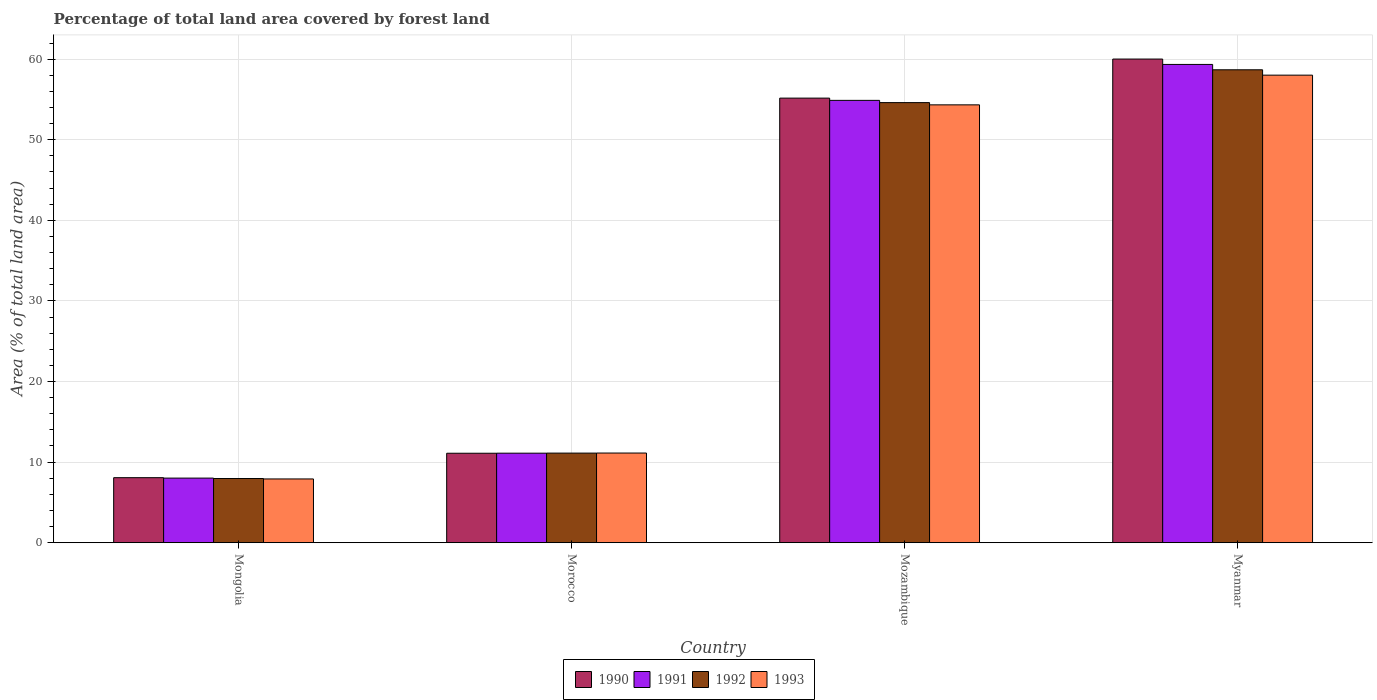How many different coloured bars are there?
Provide a short and direct response. 4. How many groups of bars are there?
Offer a terse response. 4. Are the number of bars per tick equal to the number of legend labels?
Offer a terse response. Yes. Are the number of bars on each tick of the X-axis equal?
Give a very brief answer. Yes. How many bars are there on the 2nd tick from the right?
Ensure brevity in your answer.  4. What is the label of the 4th group of bars from the left?
Provide a succinct answer. Myanmar. What is the percentage of forest land in 1991 in Myanmar?
Provide a succinct answer. 59.34. Across all countries, what is the maximum percentage of forest land in 1992?
Your response must be concise. 58.68. Across all countries, what is the minimum percentage of forest land in 1990?
Provide a succinct answer. 8.07. In which country was the percentage of forest land in 1992 maximum?
Provide a succinct answer. Myanmar. In which country was the percentage of forest land in 1990 minimum?
Give a very brief answer. Mongolia. What is the total percentage of forest land in 1992 in the graph?
Provide a short and direct response. 132.36. What is the difference between the percentage of forest land in 1993 in Mongolia and that in Mozambique?
Keep it short and to the point. -46.42. What is the difference between the percentage of forest land in 1992 in Mozambique and the percentage of forest land in 1993 in Morocco?
Provide a short and direct response. 43.48. What is the average percentage of forest land in 1990 per country?
Provide a short and direct response. 33.58. What is the difference between the percentage of forest land of/in 1993 and percentage of forest land of/in 1990 in Mongolia?
Your answer should be very brief. -0.16. What is the ratio of the percentage of forest land in 1993 in Mongolia to that in Myanmar?
Offer a very short reply. 0.14. Is the difference between the percentage of forest land in 1993 in Morocco and Myanmar greater than the difference between the percentage of forest land in 1990 in Morocco and Myanmar?
Make the answer very short. Yes. What is the difference between the highest and the second highest percentage of forest land in 1992?
Make the answer very short. 47.56. What is the difference between the highest and the lowest percentage of forest land in 1990?
Provide a succinct answer. 51.94. Is the sum of the percentage of forest land in 1993 in Morocco and Myanmar greater than the maximum percentage of forest land in 1990 across all countries?
Provide a short and direct response. Yes. What does the 2nd bar from the left in Mozambique represents?
Your answer should be very brief. 1991. Are all the bars in the graph horizontal?
Your answer should be compact. No. How many countries are there in the graph?
Keep it short and to the point. 4. What is the difference between two consecutive major ticks on the Y-axis?
Keep it short and to the point. 10. Are the values on the major ticks of Y-axis written in scientific E-notation?
Provide a succinct answer. No. Does the graph contain any zero values?
Offer a terse response. No. How are the legend labels stacked?
Provide a succinct answer. Horizontal. What is the title of the graph?
Your answer should be compact. Percentage of total land area covered by forest land. Does "2003" appear as one of the legend labels in the graph?
Keep it short and to the point. No. What is the label or title of the X-axis?
Keep it short and to the point. Country. What is the label or title of the Y-axis?
Your response must be concise. Area (% of total land area). What is the Area (% of total land area) in 1990 in Mongolia?
Offer a very short reply. 8.07. What is the Area (% of total land area) of 1991 in Mongolia?
Give a very brief answer. 8.02. What is the Area (% of total land area) in 1992 in Mongolia?
Your answer should be very brief. 7.96. What is the Area (% of total land area) of 1993 in Mongolia?
Provide a short and direct response. 7.91. What is the Area (% of total land area) of 1990 in Morocco?
Give a very brief answer. 11.1. What is the Area (% of total land area) of 1991 in Morocco?
Offer a terse response. 11.11. What is the Area (% of total land area) of 1992 in Morocco?
Ensure brevity in your answer.  11.12. What is the Area (% of total land area) of 1993 in Morocco?
Your response must be concise. 11.13. What is the Area (% of total land area) of 1990 in Mozambique?
Ensure brevity in your answer.  55.16. What is the Area (% of total land area) in 1991 in Mozambique?
Provide a succinct answer. 54.88. What is the Area (% of total land area) of 1992 in Mozambique?
Your answer should be very brief. 54.6. What is the Area (% of total land area) of 1993 in Mozambique?
Offer a terse response. 54.33. What is the Area (% of total land area) in 1990 in Myanmar?
Ensure brevity in your answer.  60.01. What is the Area (% of total land area) of 1991 in Myanmar?
Your answer should be very brief. 59.34. What is the Area (% of total land area) in 1992 in Myanmar?
Ensure brevity in your answer.  58.68. What is the Area (% of total land area) in 1993 in Myanmar?
Your answer should be very brief. 58.01. Across all countries, what is the maximum Area (% of total land area) in 1990?
Keep it short and to the point. 60.01. Across all countries, what is the maximum Area (% of total land area) in 1991?
Give a very brief answer. 59.34. Across all countries, what is the maximum Area (% of total land area) in 1992?
Your answer should be very brief. 58.68. Across all countries, what is the maximum Area (% of total land area) in 1993?
Offer a very short reply. 58.01. Across all countries, what is the minimum Area (% of total land area) in 1990?
Your answer should be very brief. 8.07. Across all countries, what is the minimum Area (% of total land area) of 1991?
Your answer should be very brief. 8.02. Across all countries, what is the minimum Area (% of total land area) in 1992?
Make the answer very short. 7.96. Across all countries, what is the minimum Area (% of total land area) of 1993?
Ensure brevity in your answer.  7.91. What is the total Area (% of total land area) of 1990 in the graph?
Ensure brevity in your answer.  134.34. What is the total Area (% of total land area) of 1991 in the graph?
Your answer should be compact. 133.35. What is the total Area (% of total land area) of 1992 in the graph?
Offer a very short reply. 132.36. What is the total Area (% of total land area) of 1993 in the graph?
Your answer should be compact. 131.38. What is the difference between the Area (% of total land area) of 1990 in Mongolia and that in Morocco?
Keep it short and to the point. -3.03. What is the difference between the Area (% of total land area) of 1991 in Mongolia and that in Morocco?
Your response must be concise. -3.09. What is the difference between the Area (% of total land area) in 1992 in Mongolia and that in Morocco?
Give a very brief answer. -3.15. What is the difference between the Area (% of total land area) of 1993 in Mongolia and that in Morocco?
Keep it short and to the point. -3.22. What is the difference between the Area (% of total land area) in 1990 in Mongolia and that in Mozambique?
Provide a succinct answer. -47.09. What is the difference between the Area (% of total land area) of 1991 in Mongolia and that in Mozambique?
Make the answer very short. -46.87. What is the difference between the Area (% of total land area) of 1992 in Mongolia and that in Mozambique?
Offer a terse response. -46.64. What is the difference between the Area (% of total land area) in 1993 in Mongolia and that in Mozambique?
Your answer should be very brief. -46.42. What is the difference between the Area (% of total land area) of 1990 in Mongolia and that in Myanmar?
Offer a very short reply. -51.94. What is the difference between the Area (% of total land area) in 1991 in Mongolia and that in Myanmar?
Provide a succinct answer. -51.33. What is the difference between the Area (% of total land area) in 1992 in Mongolia and that in Myanmar?
Make the answer very short. -50.71. What is the difference between the Area (% of total land area) of 1993 in Mongolia and that in Myanmar?
Your answer should be very brief. -50.1. What is the difference between the Area (% of total land area) in 1990 in Morocco and that in Mozambique?
Give a very brief answer. -44.06. What is the difference between the Area (% of total land area) in 1991 in Morocco and that in Mozambique?
Keep it short and to the point. -43.77. What is the difference between the Area (% of total land area) in 1992 in Morocco and that in Mozambique?
Provide a succinct answer. -43.49. What is the difference between the Area (% of total land area) in 1993 in Morocco and that in Mozambique?
Offer a terse response. -43.2. What is the difference between the Area (% of total land area) of 1990 in Morocco and that in Myanmar?
Ensure brevity in your answer.  -48.91. What is the difference between the Area (% of total land area) in 1991 in Morocco and that in Myanmar?
Ensure brevity in your answer.  -48.23. What is the difference between the Area (% of total land area) in 1992 in Morocco and that in Myanmar?
Make the answer very short. -47.56. What is the difference between the Area (% of total land area) in 1993 in Morocco and that in Myanmar?
Your answer should be compact. -46.89. What is the difference between the Area (% of total land area) in 1990 in Mozambique and that in Myanmar?
Keep it short and to the point. -4.85. What is the difference between the Area (% of total land area) of 1991 in Mozambique and that in Myanmar?
Give a very brief answer. -4.46. What is the difference between the Area (% of total land area) of 1992 in Mozambique and that in Myanmar?
Your response must be concise. -4.07. What is the difference between the Area (% of total land area) in 1993 in Mozambique and that in Myanmar?
Offer a terse response. -3.69. What is the difference between the Area (% of total land area) in 1990 in Mongolia and the Area (% of total land area) in 1991 in Morocco?
Offer a very short reply. -3.04. What is the difference between the Area (% of total land area) in 1990 in Mongolia and the Area (% of total land area) in 1992 in Morocco?
Ensure brevity in your answer.  -3.05. What is the difference between the Area (% of total land area) of 1990 in Mongolia and the Area (% of total land area) of 1993 in Morocco?
Keep it short and to the point. -3.06. What is the difference between the Area (% of total land area) of 1991 in Mongolia and the Area (% of total land area) of 1992 in Morocco?
Your answer should be compact. -3.1. What is the difference between the Area (% of total land area) in 1991 in Mongolia and the Area (% of total land area) in 1993 in Morocco?
Keep it short and to the point. -3.11. What is the difference between the Area (% of total land area) in 1992 in Mongolia and the Area (% of total land area) in 1993 in Morocco?
Your answer should be compact. -3.16. What is the difference between the Area (% of total land area) of 1990 in Mongolia and the Area (% of total land area) of 1991 in Mozambique?
Your response must be concise. -46.81. What is the difference between the Area (% of total land area) of 1990 in Mongolia and the Area (% of total land area) of 1992 in Mozambique?
Keep it short and to the point. -46.54. What is the difference between the Area (% of total land area) in 1990 in Mongolia and the Area (% of total land area) in 1993 in Mozambique?
Give a very brief answer. -46.26. What is the difference between the Area (% of total land area) in 1991 in Mongolia and the Area (% of total land area) in 1992 in Mozambique?
Your answer should be compact. -46.59. What is the difference between the Area (% of total land area) of 1991 in Mongolia and the Area (% of total land area) of 1993 in Mozambique?
Make the answer very short. -46.31. What is the difference between the Area (% of total land area) in 1992 in Mongolia and the Area (% of total land area) in 1993 in Mozambique?
Your answer should be very brief. -46.36. What is the difference between the Area (% of total land area) of 1990 in Mongolia and the Area (% of total land area) of 1991 in Myanmar?
Offer a terse response. -51.27. What is the difference between the Area (% of total land area) of 1990 in Mongolia and the Area (% of total land area) of 1992 in Myanmar?
Make the answer very short. -50.61. What is the difference between the Area (% of total land area) in 1990 in Mongolia and the Area (% of total land area) in 1993 in Myanmar?
Your response must be concise. -49.94. What is the difference between the Area (% of total land area) of 1991 in Mongolia and the Area (% of total land area) of 1992 in Myanmar?
Offer a terse response. -50.66. What is the difference between the Area (% of total land area) in 1991 in Mongolia and the Area (% of total land area) in 1993 in Myanmar?
Your response must be concise. -50. What is the difference between the Area (% of total land area) of 1992 in Mongolia and the Area (% of total land area) of 1993 in Myanmar?
Your response must be concise. -50.05. What is the difference between the Area (% of total land area) of 1990 in Morocco and the Area (% of total land area) of 1991 in Mozambique?
Keep it short and to the point. -43.78. What is the difference between the Area (% of total land area) in 1990 in Morocco and the Area (% of total land area) in 1992 in Mozambique?
Give a very brief answer. -43.5. What is the difference between the Area (% of total land area) in 1990 in Morocco and the Area (% of total land area) in 1993 in Mozambique?
Provide a succinct answer. -43.23. What is the difference between the Area (% of total land area) in 1991 in Morocco and the Area (% of total land area) in 1992 in Mozambique?
Your answer should be very brief. -43.5. What is the difference between the Area (% of total land area) of 1991 in Morocco and the Area (% of total land area) of 1993 in Mozambique?
Your answer should be compact. -43.22. What is the difference between the Area (% of total land area) in 1992 in Morocco and the Area (% of total land area) in 1993 in Mozambique?
Give a very brief answer. -43.21. What is the difference between the Area (% of total land area) in 1990 in Morocco and the Area (% of total land area) in 1991 in Myanmar?
Provide a short and direct response. -48.24. What is the difference between the Area (% of total land area) in 1990 in Morocco and the Area (% of total land area) in 1992 in Myanmar?
Provide a short and direct response. -47.58. What is the difference between the Area (% of total land area) in 1990 in Morocco and the Area (% of total land area) in 1993 in Myanmar?
Give a very brief answer. -46.91. What is the difference between the Area (% of total land area) of 1991 in Morocco and the Area (% of total land area) of 1992 in Myanmar?
Your answer should be very brief. -47.57. What is the difference between the Area (% of total land area) in 1991 in Morocco and the Area (% of total land area) in 1993 in Myanmar?
Your answer should be compact. -46.9. What is the difference between the Area (% of total land area) of 1992 in Morocco and the Area (% of total land area) of 1993 in Myanmar?
Offer a terse response. -46.89. What is the difference between the Area (% of total land area) of 1990 in Mozambique and the Area (% of total land area) of 1991 in Myanmar?
Your answer should be very brief. -4.18. What is the difference between the Area (% of total land area) of 1990 in Mozambique and the Area (% of total land area) of 1992 in Myanmar?
Your answer should be compact. -3.52. What is the difference between the Area (% of total land area) in 1990 in Mozambique and the Area (% of total land area) in 1993 in Myanmar?
Your answer should be compact. -2.85. What is the difference between the Area (% of total land area) in 1991 in Mozambique and the Area (% of total land area) in 1992 in Myanmar?
Your response must be concise. -3.79. What is the difference between the Area (% of total land area) in 1991 in Mozambique and the Area (% of total land area) in 1993 in Myanmar?
Provide a short and direct response. -3.13. What is the difference between the Area (% of total land area) in 1992 in Mozambique and the Area (% of total land area) in 1993 in Myanmar?
Offer a very short reply. -3.41. What is the average Area (% of total land area) of 1990 per country?
Provide a succinct answer. 33.58. What is the average Area (% of total land area) of 1991 per country?
Offer a terse response. 33.34. What is the average Area (% of total land area) in 1992 per country?
Provide a short and direct response. 33.09. What is the average Area (% of total land area) of 1993 per country?
Provide a succinct answer. 32.84. What is the difference between the Area (% of total land area) in 1990 and Area (% of total land area) in 1991 in Mongolia?
Your answer should be very brief. 0.05. What is the difference between the Area (% of total land area) in 1990 and Area (% of total land area) in 1992 in Mongolia?
Provide a short and direct response. 0.11. What is the difference between the Area (% of total land area) in 1990 and Area (% of total land area) in 1993 in Mongolia?
Offer a terse response. 0.16. What is the difference between the Area (% of total land area) of 1991 and Area (% of total land area) of 1992 in Mongolia?
Offer a terse response. 0.05. What is the difference between the Area (% of total land area) in 1991 and Area (% of total land area) in 1993 in Mongolia?
Ensure brevity in your answer.  0.11. What is the difference between the Area (% of total land area) of 1992 and Area (% of total land area) of 1993 in Mongolia?
Your answer should be very brief. 0.05. What is the difference between the Area (% of total land area) of 1990 and Area (% of total land area) of 1991 in Morocco?
Keep it short and to the point. -0.01. What is the difference between the Area (% of total land area) of 1990 and Area (% of total land area) of 1992 in Morocco?
Your response must be concise. -0.02. What is the difference between the Area (% of total land area) of 1990 and Area (% of total land area) of 1993 in Morocco?
Offer a very short reply. -0.03. What is the difference between the Area (% of total land area) in 1991 and Area (% of total land area) in 1992 in Morocco?
Your answer should be compact. -0.01. What is the difference between the Area (% of total land area) in 1991 and Area (% of total land area) in 1993 in Morocco?
Your response must be concise. -0.02. What is the difference between the Area (% of total land area) of 1992 and Area (% of total land area) of 1993 in Morocco?
Your answer should be very brief. -0.01. What is the difference between the Area (% of total land area) in 1990 and Area (% of total land area) in 1991 in Mozambique?
Your response must be concise. 0.28. What is the difference between the Area (% of total land area) of 1990 and Area (% of total land area) of 1992 in Mozambique?
Your response must be concise. 0.56. What is the difference between the Area (% of total land area) of 1990 and Area (% of total land area) of 1993 in Mozambique?
Offer a very short reply. 0.84. What is the difference between the Area (% of total land area) of 1991 and Area (% of total land area) of 1992 in Mozambique?
Provide a short and direct response. 0.28. What is the difference between the Area (% of total land area) of 1991 and Area (% of total land area) of 1993 in Mozambique?
Offer a very short reply. 0.56. What is the difference between the Area (% of total land area) in 1992 and Area (% of total land area) in 1993 in Mozambique?
Your answer should be compact. 0.28. What is the difference between the Area (% of total land area) in 1990 and Area (% of total land area) in 1991 in Myanmar?
Your response must be concise. 0.67. What is the difference between the Area (% of total land area) of 1990 and Area (% of total land area) of 1992 in Myanmar?
Your answer should be compact. 1.33. What is the difference between the Area (% of total land area) in 1990 and Area (% of total land area) in 1993 in Myanmar?
Keep it short and to the point. 2. What is the difference between the Area (% of total land area) in 1991 and Area (% of total land area) in 1992 in Myanmar?
Ensure brevity in your answer.  0.67. What is the difference between the Area (% of total land area) of 1991 and Area (% of total land area) of 1993 in Myanmar?
Provide a succinct answer. 1.33. What is the difference between the Area (% of total land area) of 1992 and Area (% of total land area) of 1993 in Myanmar?
Your answer should be very brief. 0.67. What is the ratio of the Area (% of total land area) of 1990 in Mongolia to that in Morocco?
Provide a short and direct response. 0.73. What is the ratio of the Area (% of total land area) in 1991 in Mongolia to that in Morocco?
Your response must be concise. 0.72. What is the ratio of the Area (% of total land area) in 1992 in Mongolia to that in Morocco?
Ensure brevity in your answer.  0.72. What is the ratio of the Area (% of total land area) of 1993 in Mongolia to that in Morocco?
Offer a very short reply. 0.71. What is the ratio of the Area (% of total land area) of 1990 in Mongolia to that in Mozambique?
Provide a succinct answer. 0.15. What is the ratio of the Area (% of total land area) in 1991 in Mongolia to that in Mozambique?
Ensure brevity in your answer.  0.15. What is the ratio of the Area (% of total land area) in 1992 in Mongolia to that in Mozambique?
Give a very brief answer. 0.15. What is the ratio of the Area (% of total land area) in 1993 in Mongolia to that in Mozambique?
Your response must be concise. 0.15. What is the ratio of the Area (% of total land area) in 1990 in Mongolia to that in Myanmar?
Give a very brief answer. 0.13. What is the ratio of the Area (% of total land area) of 1991 in Mongolia to that in Myanmar?
Offer a very short reply. 0.14. What is the ratio of the Area (% of total land area) of 1992 in Mongolia to that in Myanmar?
Ensure brevity in your answer.  0.14. What is the ratio of the Area (% of total land area) of 1993 in Mongolia to that in Myanmar?
Give a very brief answer. 0.14. What is the ratio of the Area (% of total land area) in 1990 in Morocco to that in Mozambique?
Your response must be concise. 0.2. What is the ratio of the Area (% of total land area) in 1991 in Morocco to that in Mozambique?
Give a very brief answer. 0.2. What is the ratio of the Area (% of total land area) in 1992 in Morocco to that in Mozambique?
Provide a short and direct response. 0.2. What is the ratio of the Area (% of total land area) in 1993 in Morocco to that in Mozambique?
Give a very brief answer. 0.2. What is the ratio of the Area (% of total land area) of 1990 in Morocco to that in Myanmar?
Your response must be concise. 0.18. What is the ratio of the Area (% of total land area) of 1991 in Morocco to that in Myanmar?
Offer a very short reply. 0.19. What is the ratio of the Area (% of total land area) of 1992 in Morocco to that in Myanmar?
Make the answer very short. 0.19. What is the ratio of the Area (% of total land area) of 1993 in Morocco to that in Myanmar?
Your answer should be very brief. 0.19. What is the ratio of the Area (% of total land area) in 1990 in Mozambique to that in Myanmar?
Your response must be concise. 0.92. What is the ratio of the Area (% of total land area) of 1991 in Mozambique to that in Myanmar?
Give a very brief answer. 0.92. What is the ratio of the Area (% of total land area) of 1992 in Mozambique to that in Myanmar?
Keep it short and to the point. 0.93. What is the ratio of the Area (% of total land area) of 1993 in Mozambique to that in Myanmar?
Offer a very short reply. 0.94. What is the difference between the highest and the second highest Area (% of total land area) of 1990?
Give a very brief answer. 4.85. What is the difference between the highest and the second highest Area (% of total land area) of 1991?
Your response must be concise. 4.46. What is the difference between the highest and the second highest Area (% of total land area) of 1992?
Your answer should be very brief. 4.07. What is the difference between the highest and the second highest Area (% of total land area) in 1993?
Your response must be concise. 3.69. What is the difference between the highest and the lowest Area (% of total land area) in 1990?
Your answer should be very brief. 51.94. What is the difference between the highest and the lowest Area (% of total land area) of 1991?
Ensure brevity in your answer.  51.33. What is the difference between the highest and the lowest Area (% of total land area) in 1992?
Your response must be concise. 50.71. What is the difference between the highest and the lowest Area (% of total land area) of 1993?
Provide a short and direct response. 50.1. 